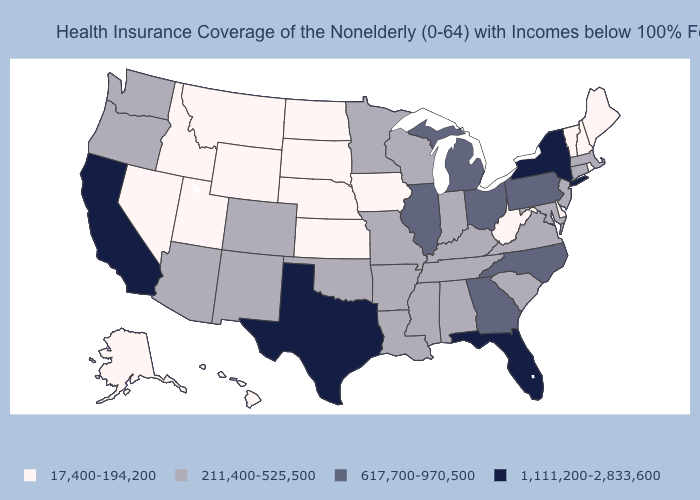Among the states that border Georgia , which have the lowest value?
Answer briefly. Alabama, South Carolina, Tennessee. Which states have the lowest value in the USA?
Concise answer only. Alaska, Delaware, Hawaii, Idaho, Iowa, Kansas, Maine, Montana, Nebraska, Nevada, New Hampshire, North Dakota, Rhode Island, South Dakota, Utah, Vermont, West Virginia, Wyoming. Name the states that have a value in the range 211,400-525,500?
Keep it brief. Alabama, Arizona, Arkansas, Colorado, Connecticut, Indiana, Kentucky, Louisiana, Maryland, Massachusetts, Minnesota, Mississippi, Missouri, New Jersey, New Mexico, Oklahoma, Oregon, South Carolina, Tennessee, Virginia, Washington, Wisconsin. Is the legend a continuous bar?
Be succinct. No. What is the value of Nevada?
Answer briefly. 17,400-194,200. Name the states that have a value in the range 1,111,200-2,833,600?
Give a very brief answer. California, Florida, New York, Texas. Which states have the lowest value in the USA?
Short answer required. Alaska, Delaware, Hawaii, Idaho, Iowa, Kansas, Maine, Montana, Nebraska, Nevada, New Hampshire, North Dakota, Rhode Island, South Dakota, Utah, Vermont, West Virginia, Wyoming. Which states hav the highest value in the South?
Keep it brief. Florida, Texas. What is the highest value in the Northeast ?
Short answer required. 1,111,200-2,833,600. Name the states that have a value in the range 211,400-525,500?
Be succinct. Alabama, Arizona, Arkansas, Colorado, Connecticut, Indiana, Kentucky, Louisiana, Maryland, Massachusetts, Minnesota, Mississippi, Missouri, New Jersey, New Mexico, Oklahoma, Oregon, South Carolina, Tennessee, Virginia, Washington, Wisconsin. Which states hav the highest value in the West?
Short answer required. California. How many symbols are there in the legend?
Concise answer only. 4. Does Massachusetts have the same value as Wisconsin?
Be succinct. Yes. Name the states that have a value in the range 617,700-970,500?
Short answer required. Georgia, Illinois, Michigan, North Carolina, Ohio, Pennsylvania. Is the legend a continuous bar?
Answer briefly. No. 